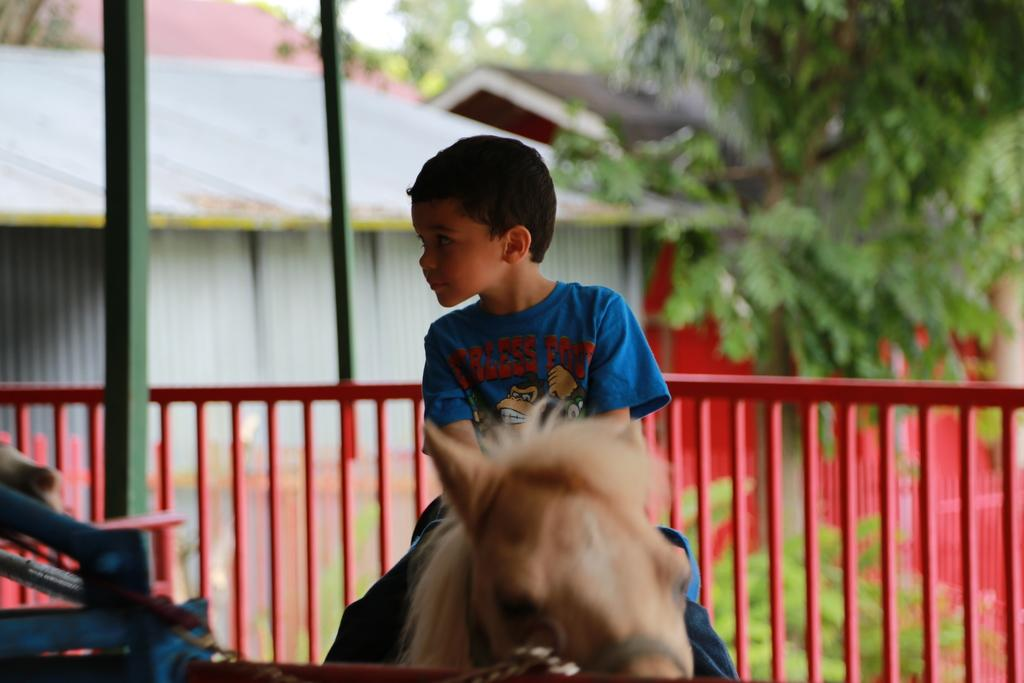What is the main subject of the image? There is a child in the image. What is the child doing in the image? The child is sitting on a horse. What can be seen in the background of the image? There is a railing, trees, a building, and the sky visible in the background of the image. What is the name of the horse in the image? The provided facts do not mention the name of the horse, so we cannot determine its name from the image. 